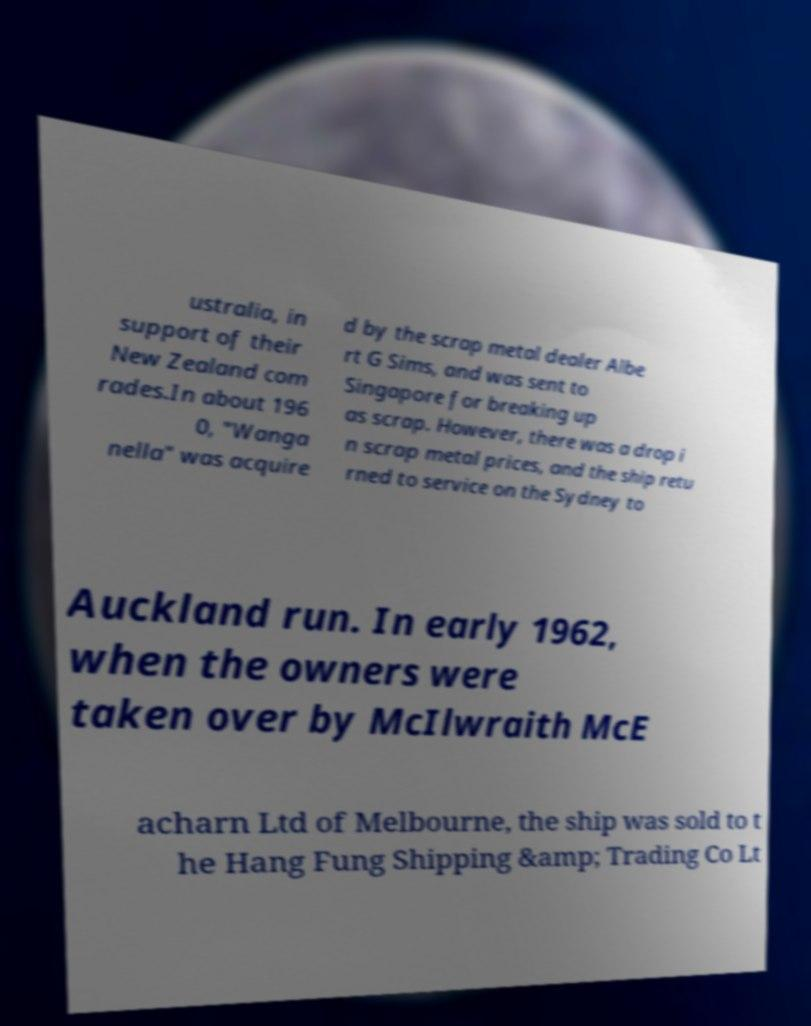What messages or text are displayed in this image? I need them in a readable, typed format. ustralia, in support of their New Zealand com rades.In about 196 0, "Wanga nella" was acquire d by the scrap metal dealer Albe rt G Sims, and was sent to Singapore for breaking up as scrap. However, there was a drop i n scrap metal prices, and the ship retu rned to service on the Sydney to Auckland run. In early 1962, when the owners were taken over by McIlwraith McE acharn Ltd of Melbourne, the ship was sold to t he Hang Fung Shipping &amp; Trading Co Lt 